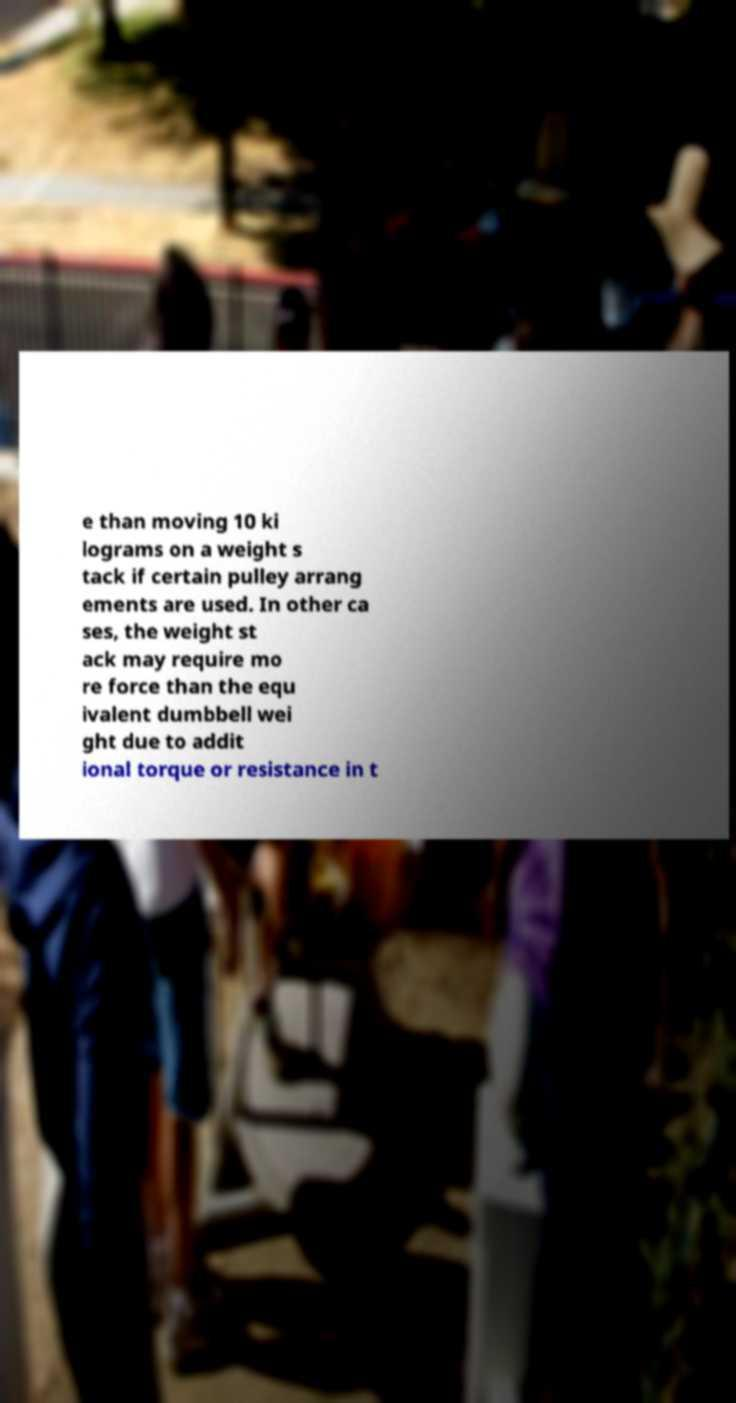Can you read and provide the text displayed in the image?This photo seems to have some interesting text. Can you extract and type it out for me? e than moving 10 ki lograms on a weight s tack if certain pulley arrang ements are used. In other ca ses, the weight st ack may require mo re force than the equ ivalent dumbbell wei ght due to addit ional torque or resistance in t 